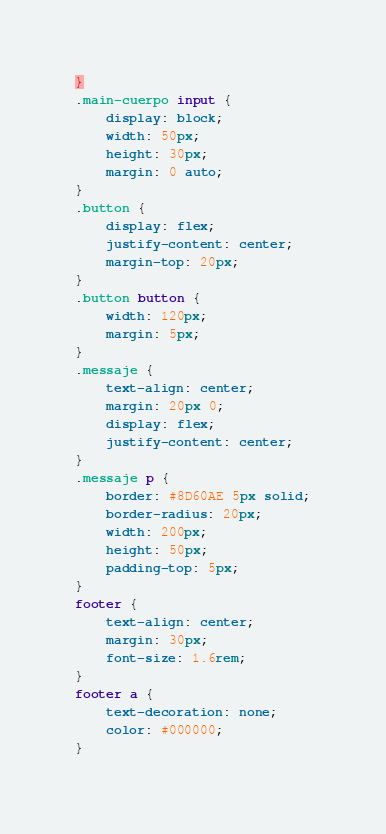<code> <loc_0><loc_0><loc_500><loc_500><_CSS_>}
.main-cuerpo input {
    display: block;
    width: 50px;
    height: 30px;
    margin: 0 auto;  
}
.button {
    display: flex;
    justify-content: center;
    margin-top: 20px;
}
.button button {
    width: 120px;
    margin: 5px;
}
.messaje {
    text-align: center;
    margin: 20px 0;
    display: flex;
    justify-content: center;
}
.messaje p {
    border: #8D60AE 5px solid;
    border-radius: 20px;
    width: 200px;
    height: 50px;
    padding-top: 5px;
}
footer {
    text-align: center;
    margin: 30px;
    font-size: 1.6rem;
}
footer a {
    text-decoration: none;
    color: #000000;
}</code> 